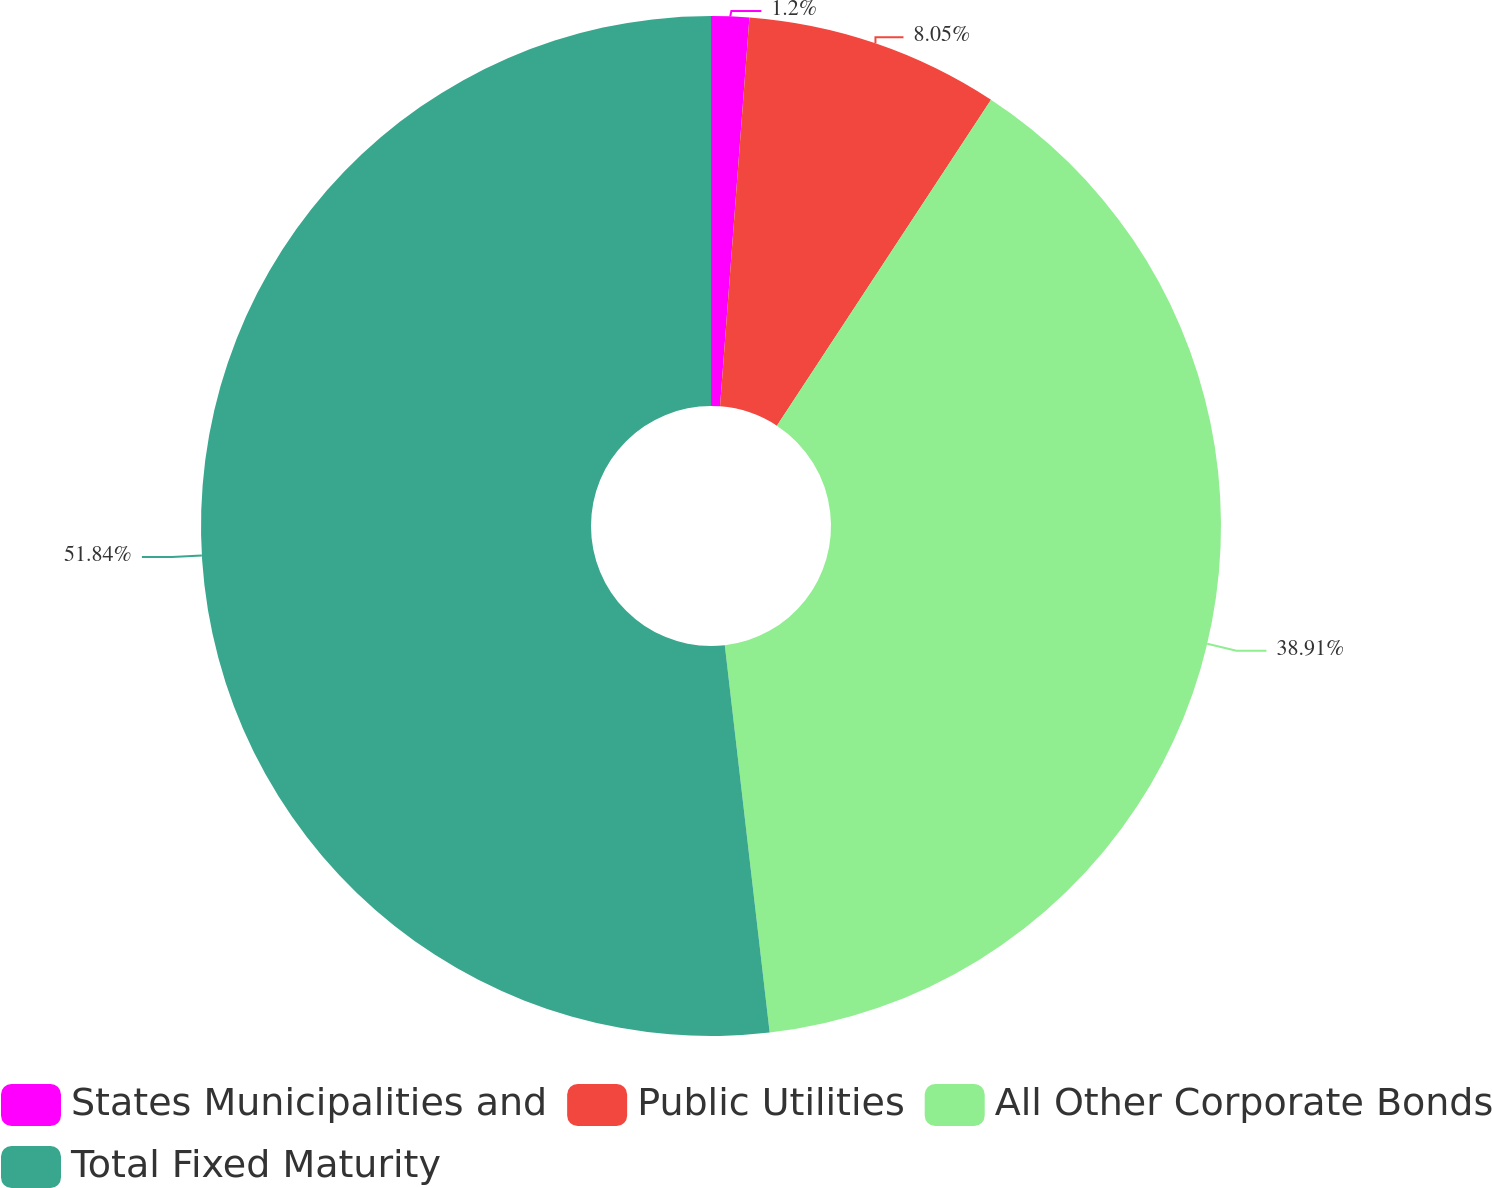Convert chart. <chart><loc_0><loc_0><loc_500><loc_500><pie_chart><fcel>States Municipalities and<fcel>Public Utilities<fcel>All Other Corporate Bonds<fcel>Total Fixed Maturity<nl><fcel>1.2%<fcel>8.05%<fcel>38.91%<fcel>51.83%<nl></chart> 